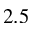Convert formula to latex. <formula><loc_0><loc_0><loc_500><loc_500>2 . 5</formula> 